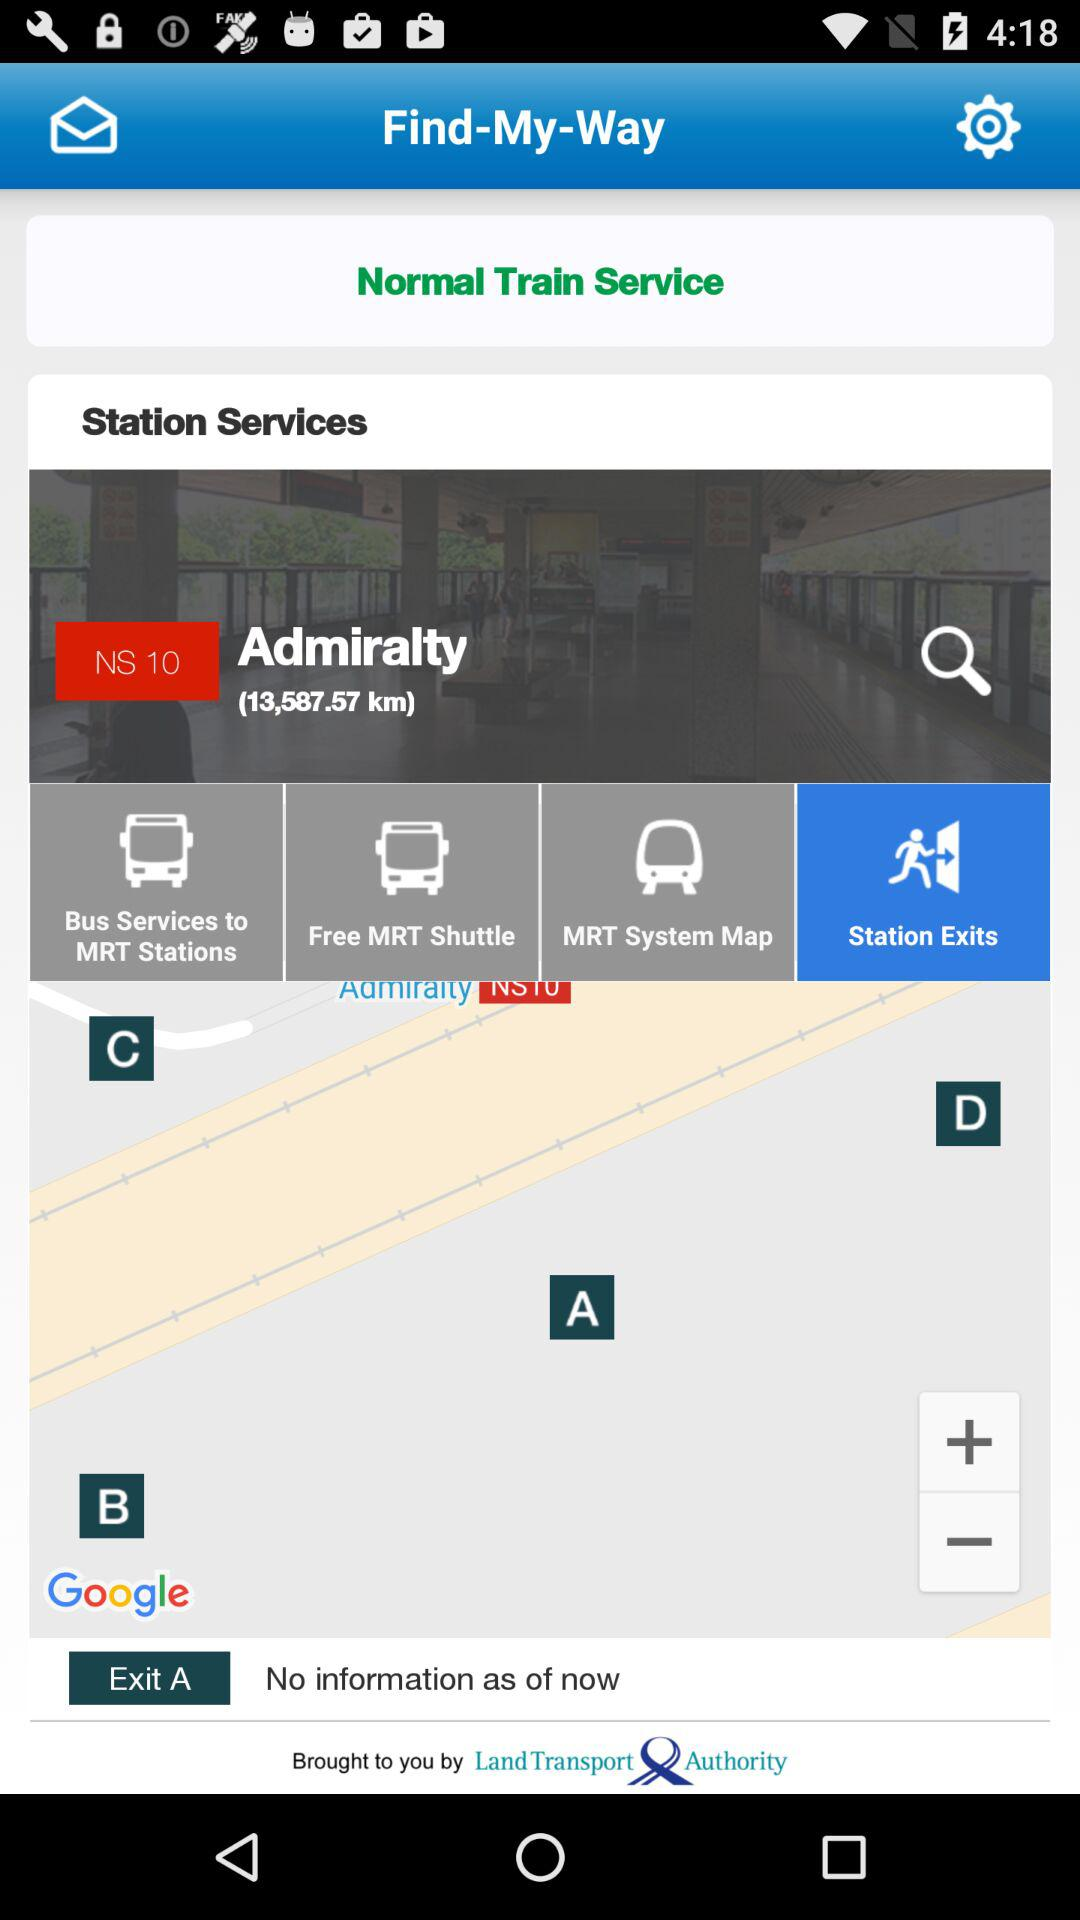What is the name of the station? The name of the station is "Admiralty". 